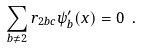Convert formula to latex. <formula><loc_0><loc_0><loc_500><loc_500>\sum _ { b \ne 2 } r _ { 2 b c } \psi _ { b } ^ { \prime } ( x ) = 0 \ .</formula> 